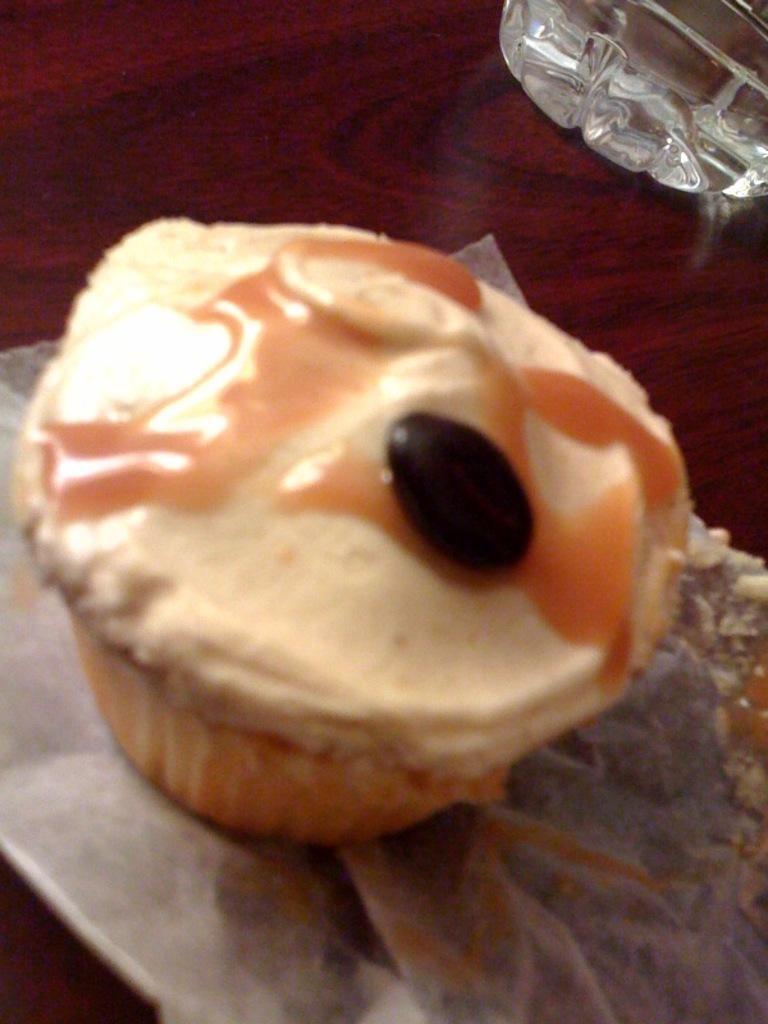In one or two sentences, can you explain what this image depicts? In this picture we can observe cupcake which is in cream color, placed on the maroon color table. There is a glass on the right side. 